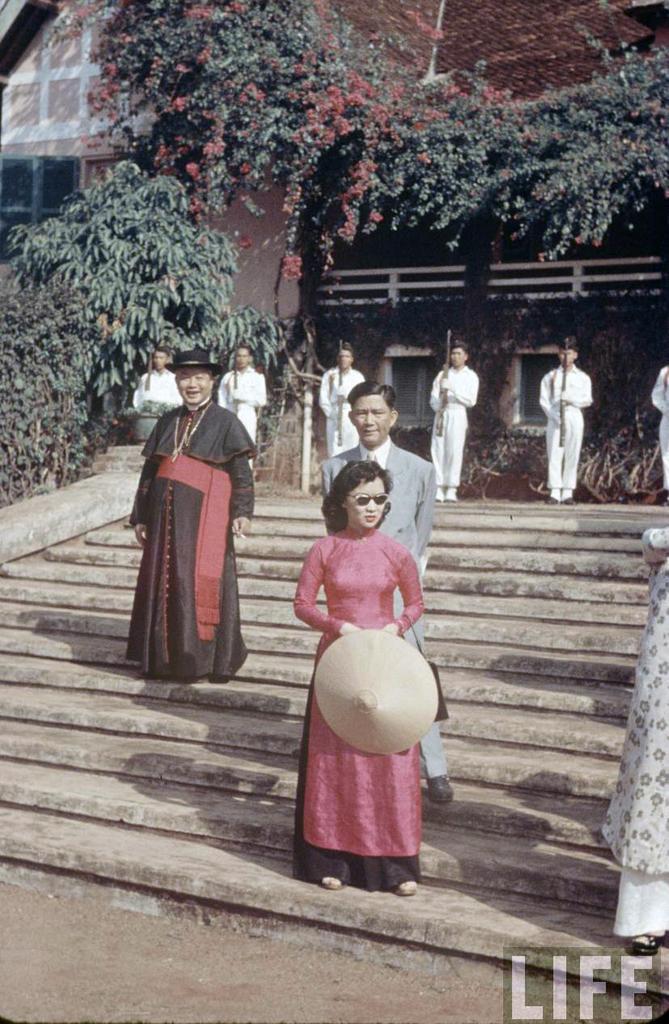In one or two sentences, can you explain what this image depicts? In this picture we can see some people standing and holding guns with their hands and some people standing on steps and in the background we can see trees, building with windows. 